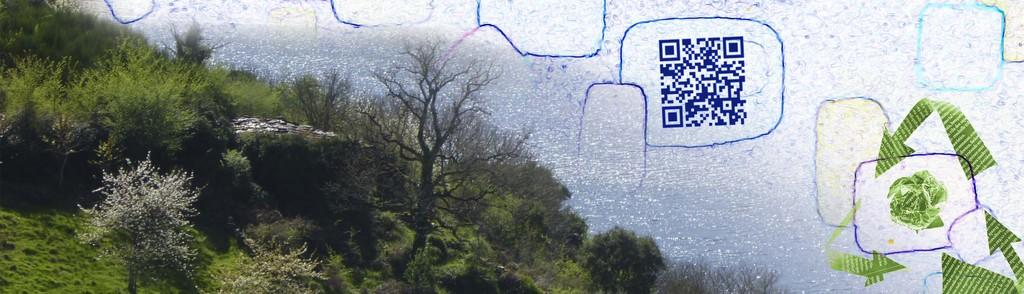What type of vegetation is present in the image? There is grass and trees in the image. What natural element can be seen in the image? There is water visible in the image. What type of modern technology is present in the image? There is a QR code in the image. What activity is the grass involved in within the image? The grass is not involved in any activity within the image; it is a stationary element. How does the stream flow through the image? There is no stream present in the image; only water is visible. 